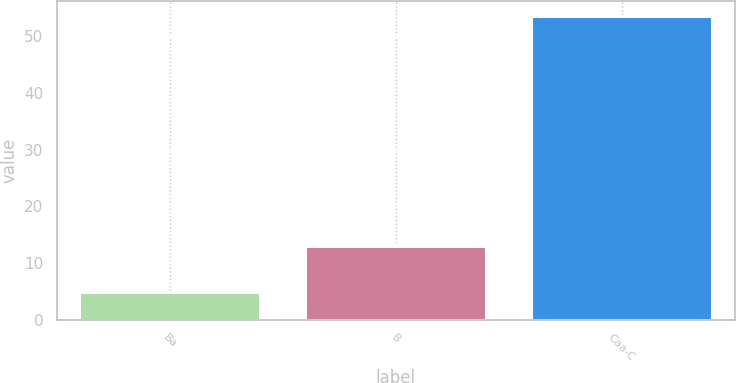Convert chart. <chart><loc_0><loc_0><loc_500><loc_500><bar_chart><fcel>Ba<fcel>B<fcel>Caa-C<nl><fcel>4.8<fcel>12.9<fcel>53.6<nl></chart> 